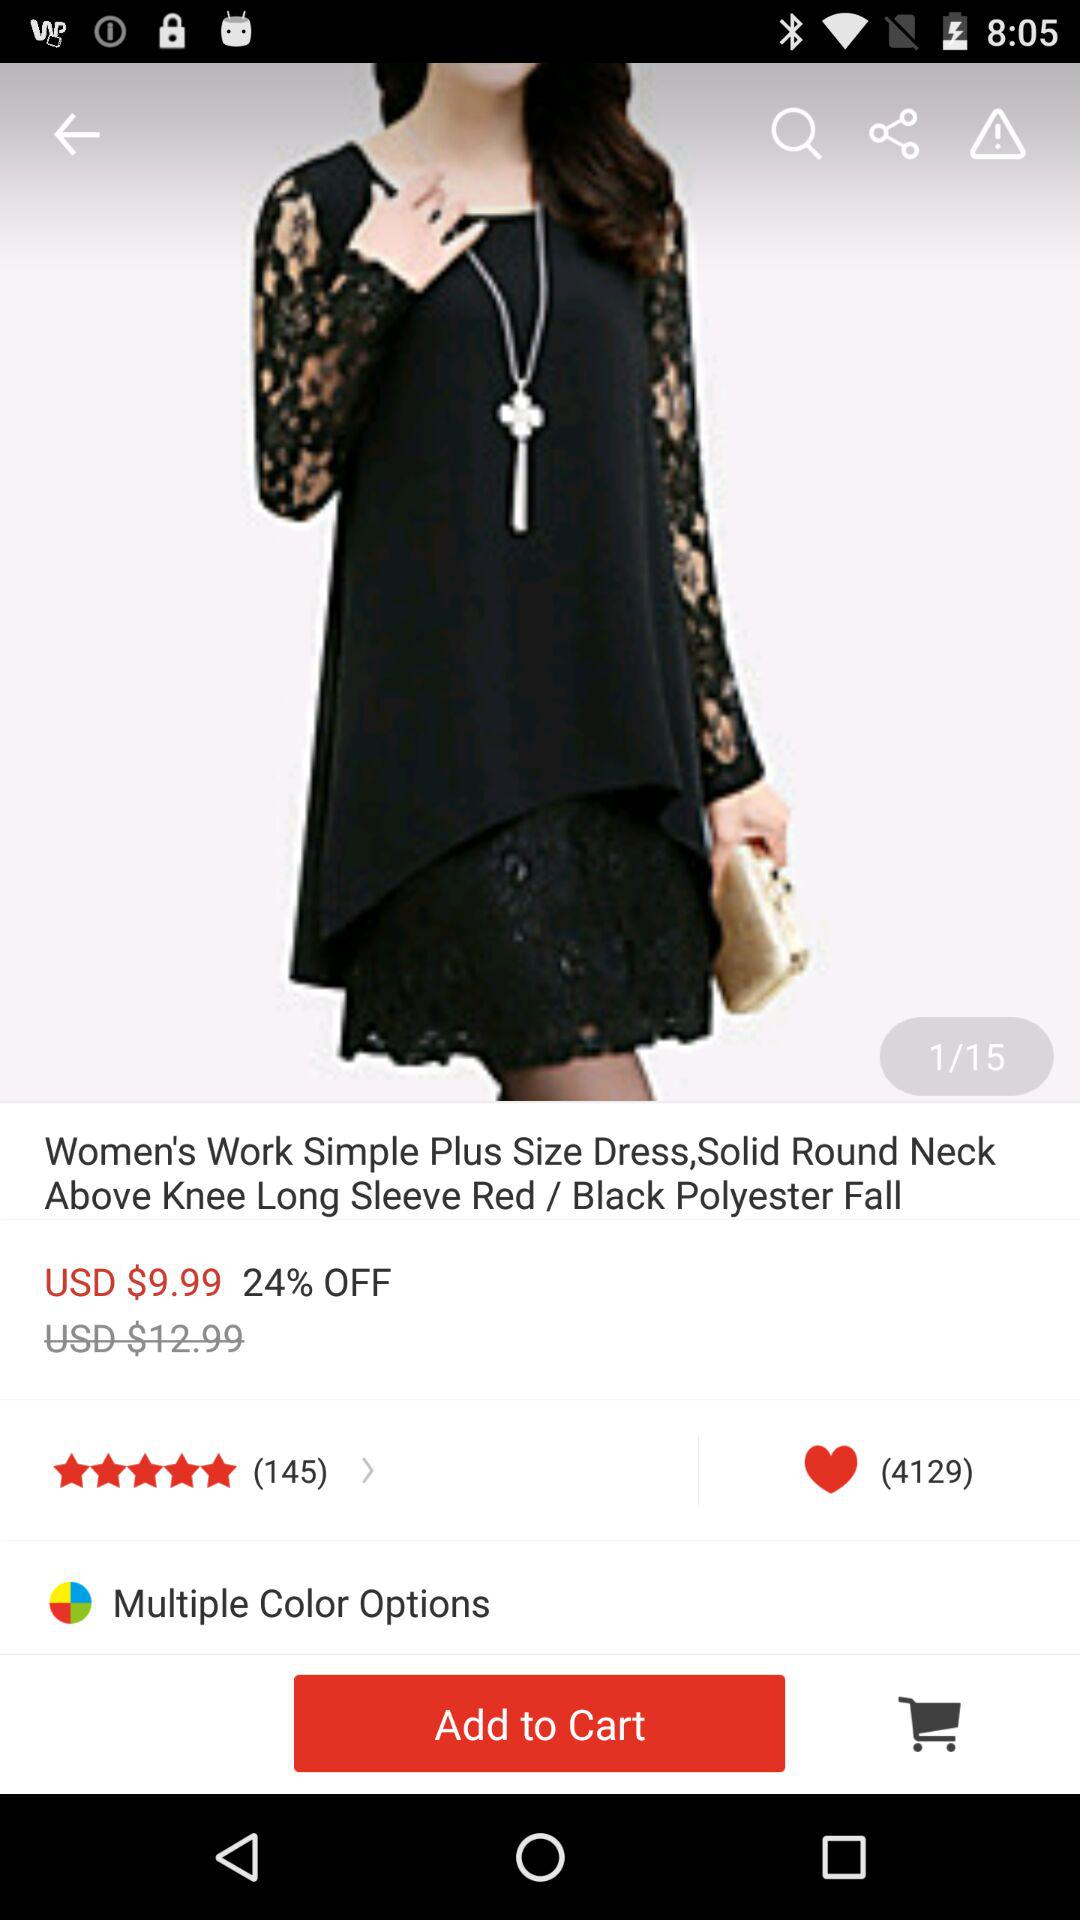What is the price of "Starry Night Sky Projector"? The price is 5.94 USD. 